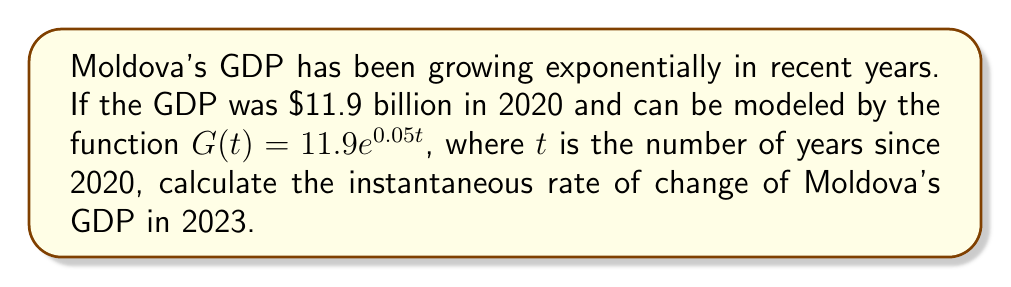Show me your answer to this math problem. To find the instantaneous rate of change of Moldova's GDP in 2023, we need to follow these steps:

1) The given function for Moldova's GDP is:
   $G(t) = 11.9e^{0.05t}$, where $t$ is years since 2020

2) To find the rate of change, we need to differentiate $G(t)$ with respect to $t$:
   $$\frac{dG}{dt} = 11.9 \cdot 0.05e^{0.05t} = 0.595e^{0.05t}$$

3) This derivative gives us the instantaneous rate of change at any time $t$

4) To find the rate of change in 2023, we need to calculate $t$:
   2023 is 3 years after 2020, so $t = 3$

5) Now, let's substitute $t = 3$ into our derivative function:
   $$\frac{dG}{dt}|_{t=3} = 0.595e^{0.05(3)} = 0.595e^{0.15}$$

6) Calculate this value:
   $$0.595e^{0.15} \approx 0.689$$

7) The units for this rate of change are billions of dollars per year

Therefore, the instantaneous rate of change of Moldova's GDP in 2023 is approximately $0.689 billion dollars per year.
Answer: $0.689 billion $/year 